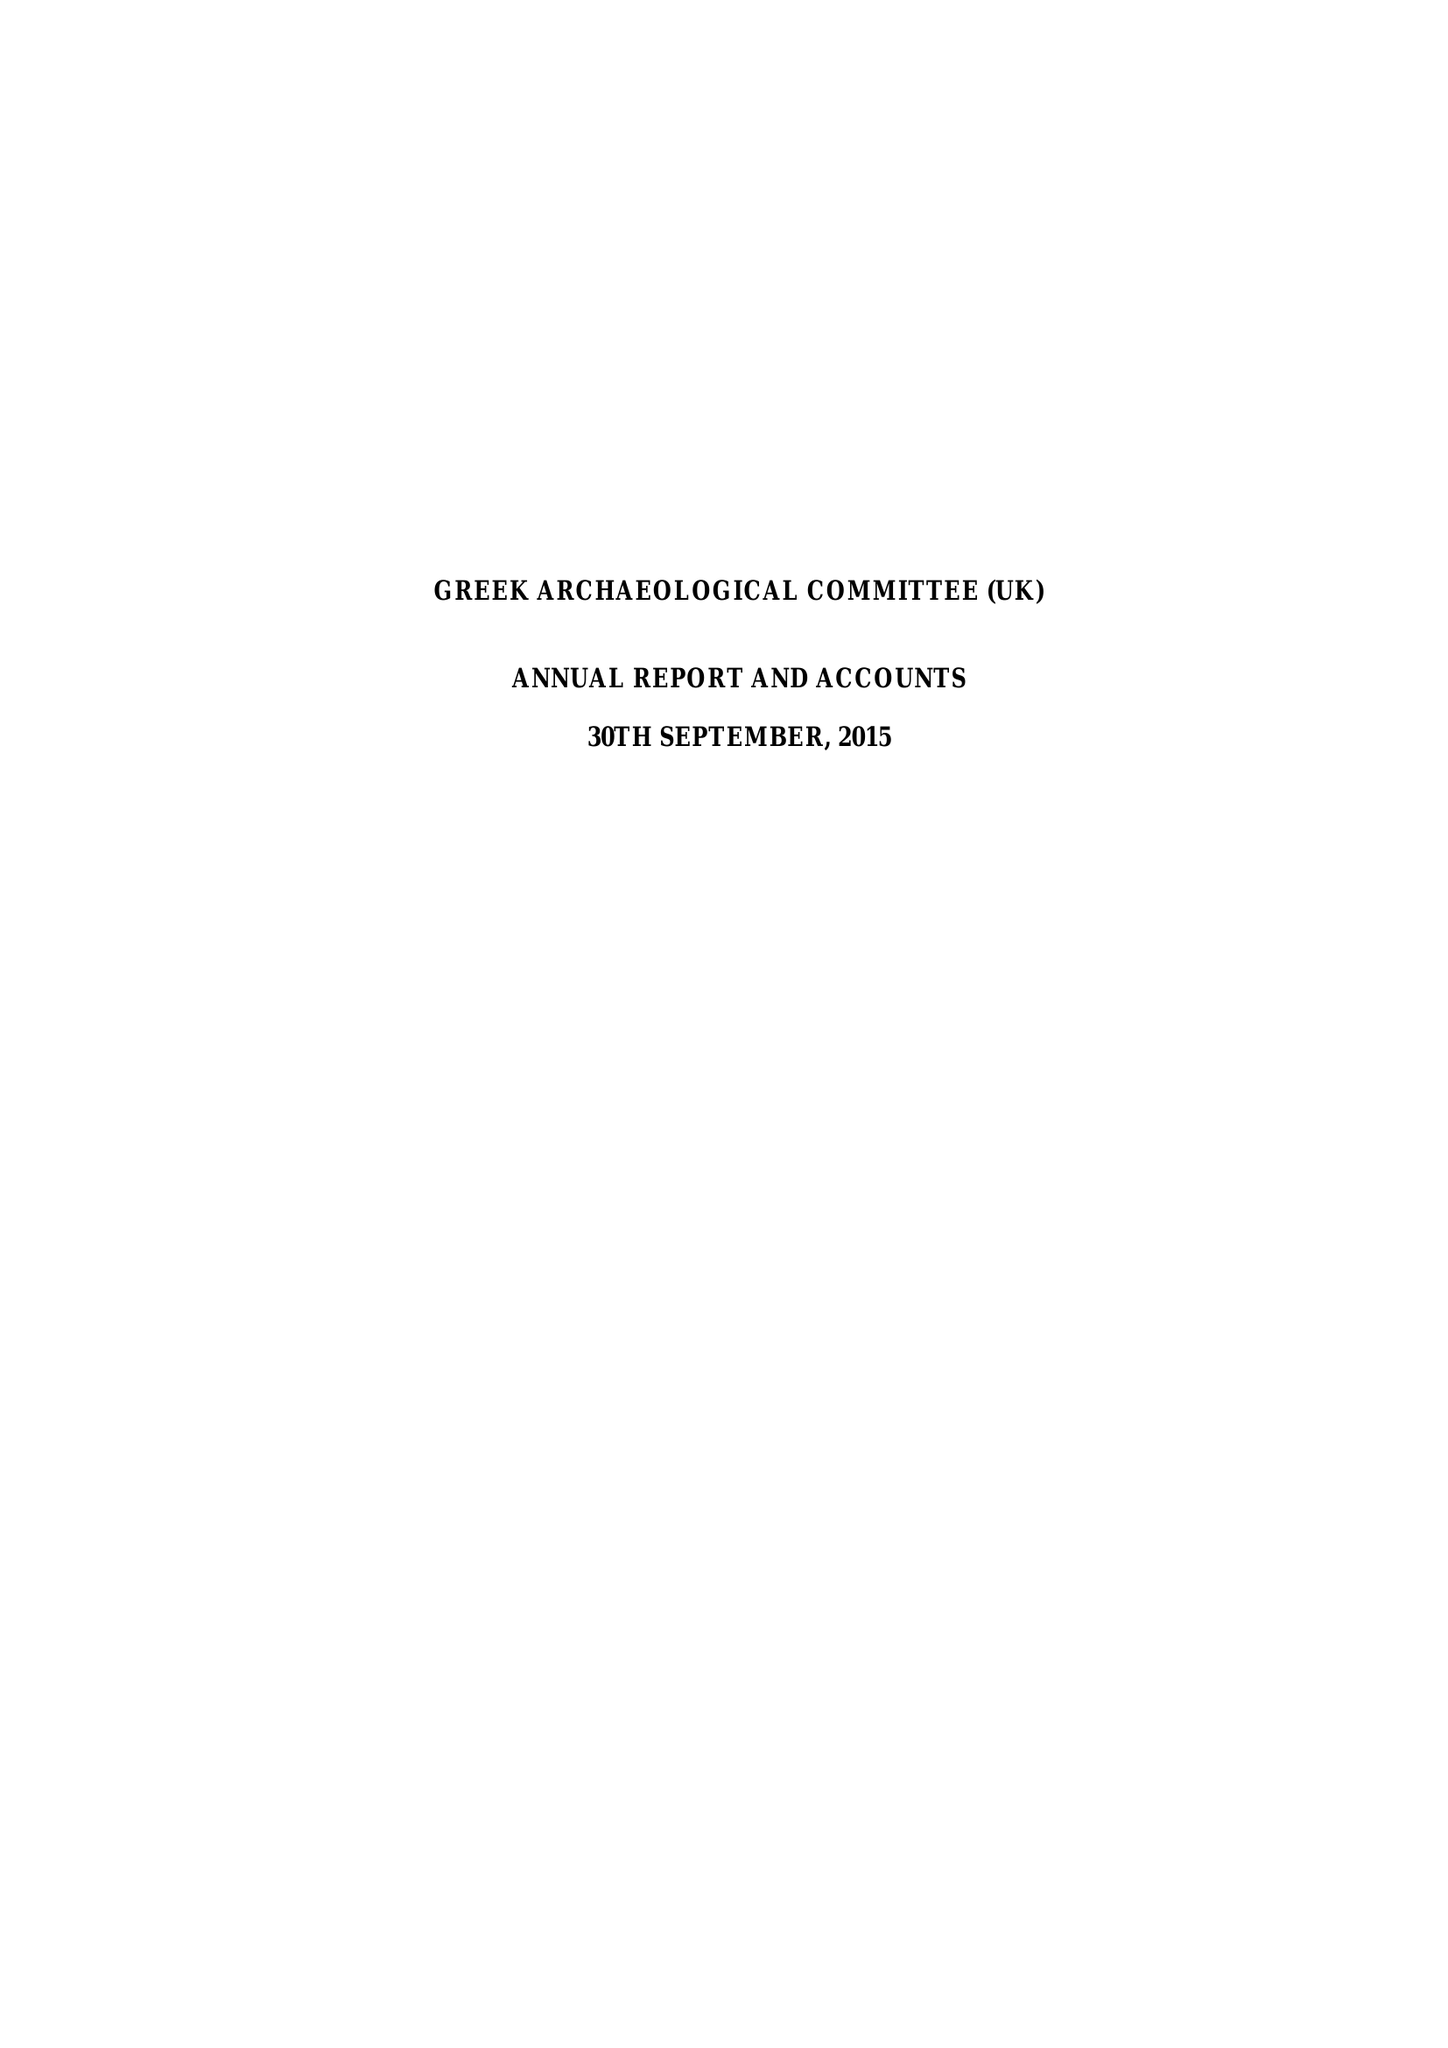What is the value for the charity_number?
Answer the question using a single word or phrase. 1013176 